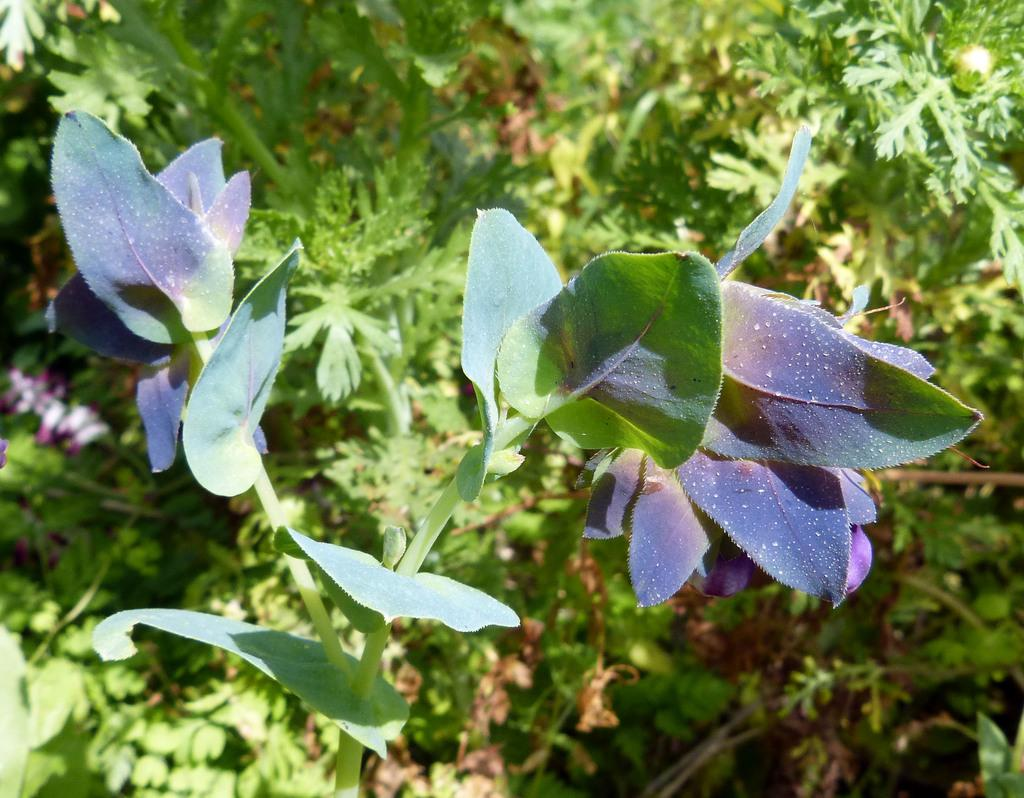What is located on the left side of the image? There is a plant on the left side of the image. What can be observed about the plant's appearance? The plant has leaves in a green and blue color combination. What else can be seen in the image related to plants? There are other plants visible in the background of the image. What type of linen is being used to cover the farm in the image? There is no farm or linen present in the image; it features a plant with green and blue leaves and other plants in the background. 